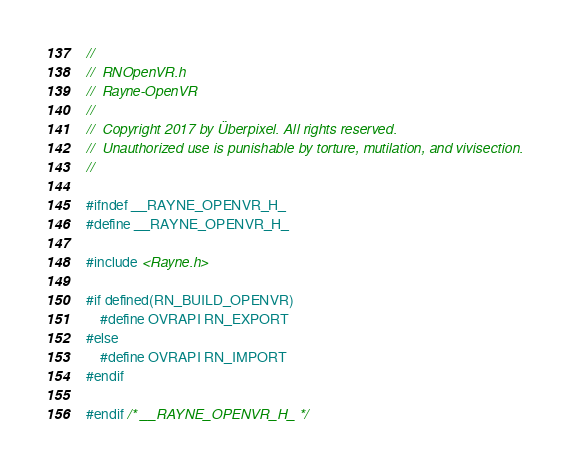<code> <loc_0><loc_0><loc_500><loc_500><_C_>//
//  RNOpenVR.h
//  Rayne-OpenVR
//
//  Copyright 2017 by Überpixel. All rights reserved.
//  Unauthorized use is punishable by torture, mutilation, and vivisection.
//

#ifndef __RAYNE_OPENVR_H_
#define __RAYNE_OPENVR_H_

#include <Rayne.h>

#if defined(RN_BUILD_OPENVR)
	#define OVRAPI RN_EXPORT
#else
	#define OVRAPI RN_IMPORT
#endif

#endif /* __RAYNE_OPENVR_H_ */
</code> 